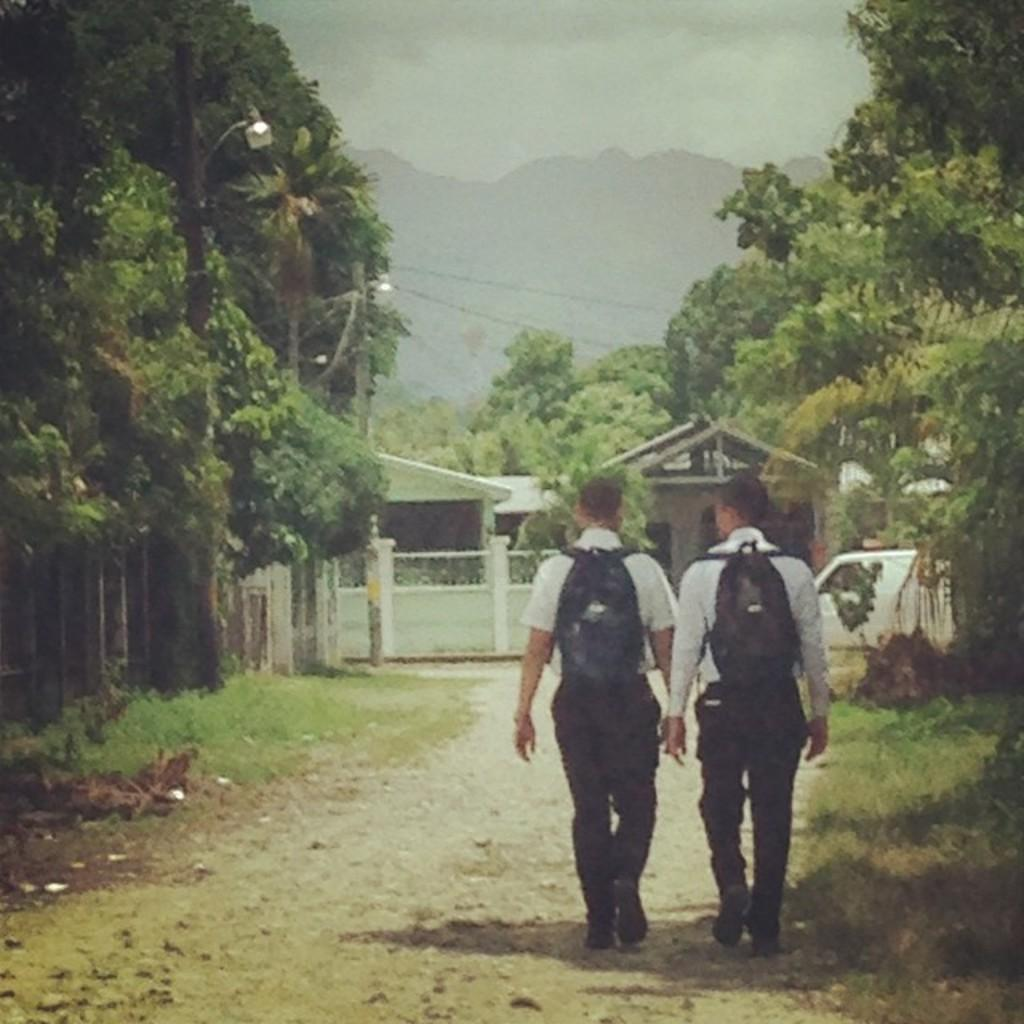What are the two people in the image doing? The two people are walking on the right side of the image. What can be seen on the left side of the image? There are trees on the left side of the image. What is located in the center of the image? There is a gate in the center of the image. What is visible at the top of the image? There is a hill and the sky visible at the top of the image. Where is the nearest park to the location depicted in the image? The provided facts do not mention a park or its location, so it cannot be determined from the image. Is there a prison visible in the image? No, there is no prison present in the image. 